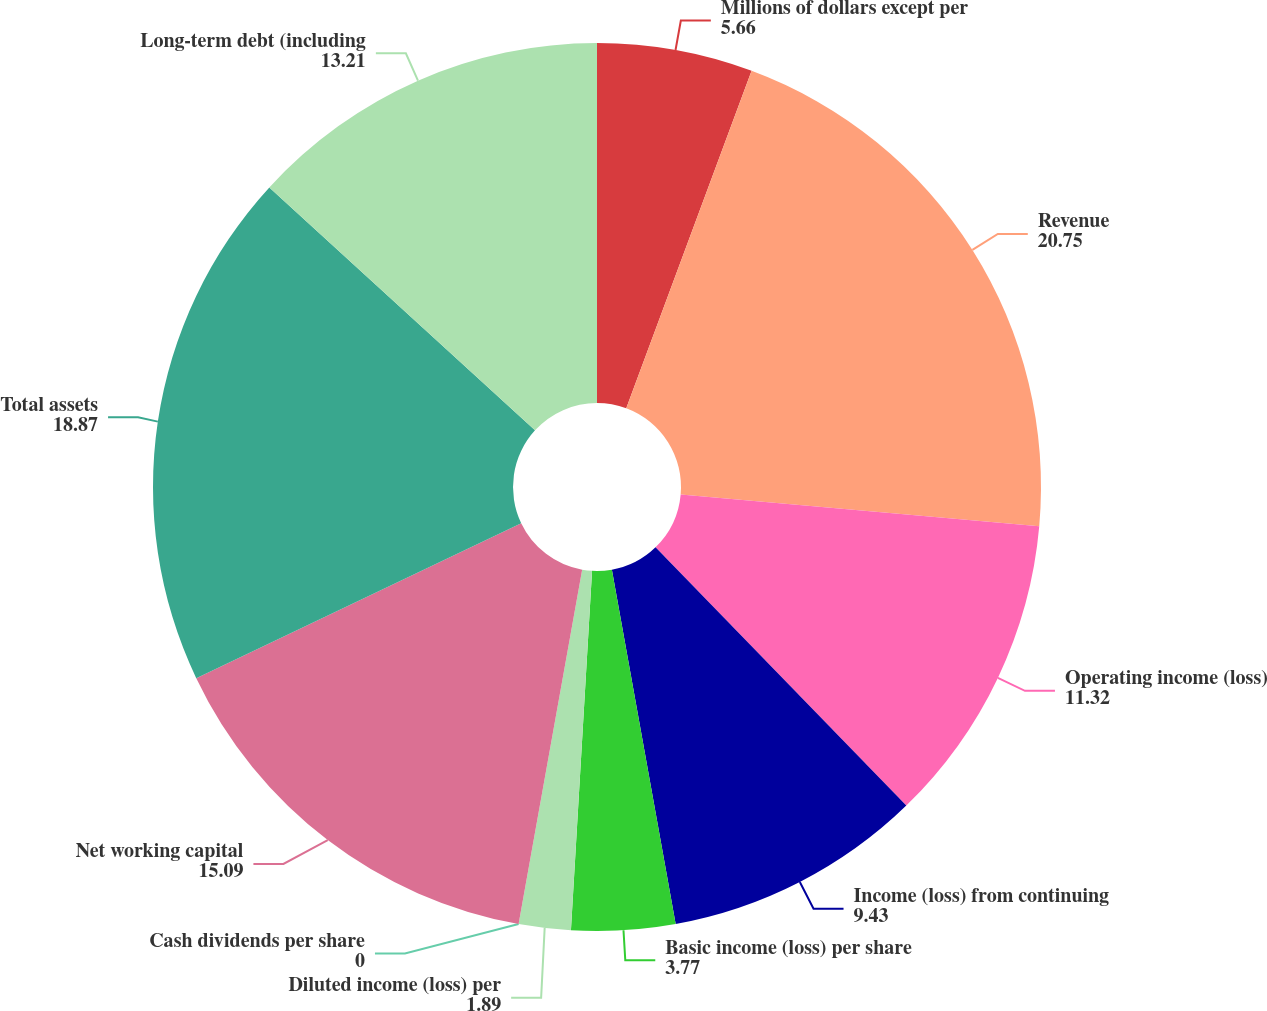Convert chart. <chart><loc_0><loc_0><loc_500><loc_500><pie_chart><fcel>Millions of dollars except per<fcel>Revenue<fcel>Operating income (loss)<fcel>Income (loss) from continuing<fcel>Basic income (loss) per share<fcel>Diluted income (loss) per<fcel>Cash dividends per share<fcel>Net working capital<fcel>Total assets<fcel>Long-term debt (including<nl><fcel>5.66%<fcel>20.75%<fcel>11.32%<fcel>9.43%<fcel>3.77%<fcel>1.89%<fcel>0.0%<fcel>15.09%<fcel>18.87%<fcel>13.21%<nl></chart> 